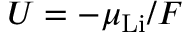<formula> <loc_0><loc_0><loc_500><loc_500>U = - \mu _ { L i } / F</formula> 